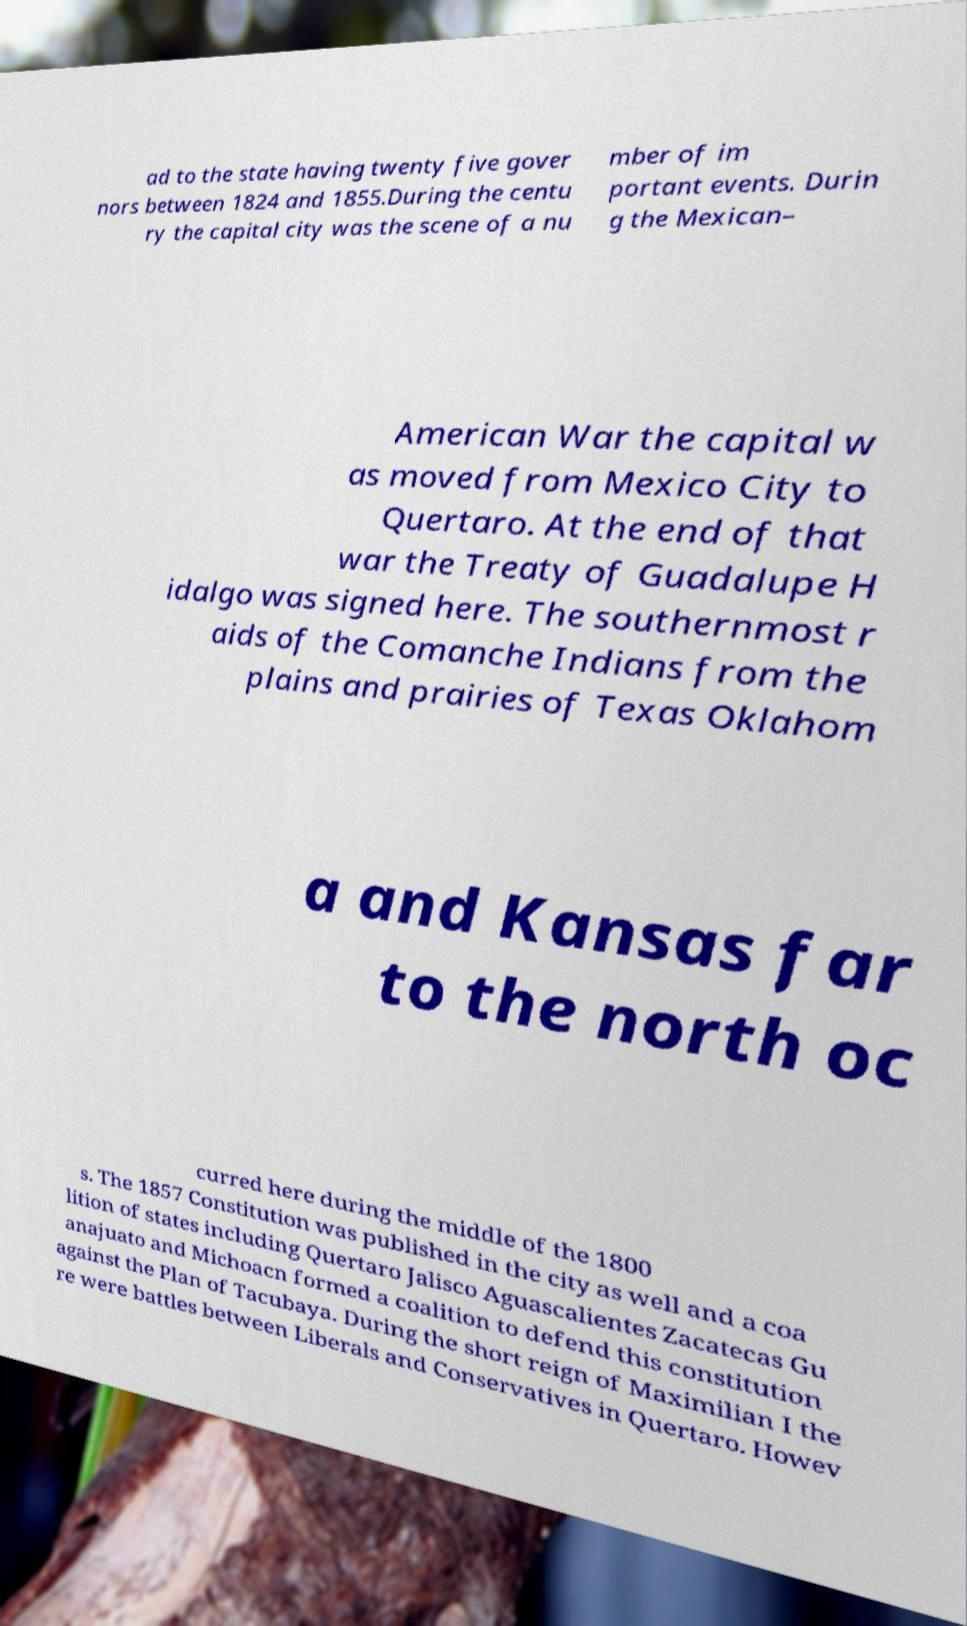Can you accurately transcribe the text from the provided image for me? ad to the state having twenty five gover nors between 1824 and 1855.During the centu ry the capital city was the scene of a nu mber of im portant events. Durin g the Mexican– American War the capital w as moved from Mexico City to Quertaro. At the end of that war the Treaty of Guadalupe H idalgo was signed here. The southernmost r aids of the Comanche Indians from the plains and prairies of Texas Oklahom a and Kansas far to the north oc curred here during the middle of the 1800 s. The 1857 Constitution was published in the city as well and a coa lition of states including Quertaro Jalisco Aguascalientes Zacatecas Gu anajuato and Michoacn formed a coalition to defend this constitution against the Plan of Tacubaya. During the short reign of Maximilian I the re were battles between Liberals and Conservatives in Quertaro. Howev 